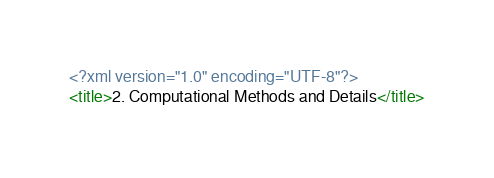Convert code to text. <code><loc_0><loc_0><loc_500><loc_500><_XML_><?xml version="1.0" encoding="UTF-8"?>
<title>2. Computational Methods and Details</title>
</code> 